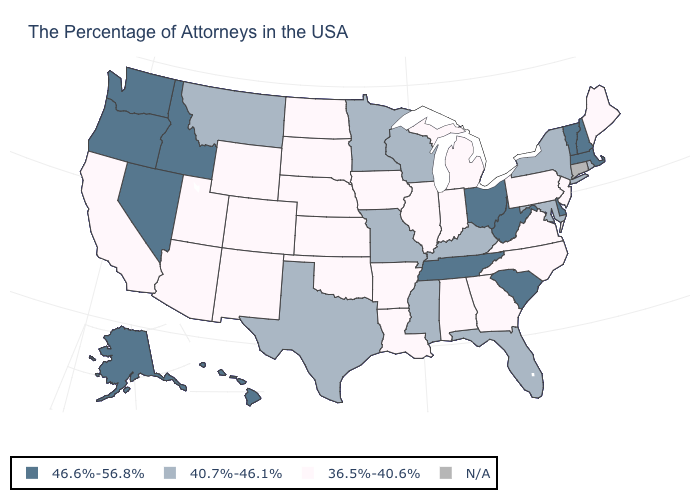What is the value of Delaware?
Be succinct. 46.6%-56.8%. What is the value of Ohio?
Keep it brief. 46.6%-56.8%. Name the states that have a value in the range 40.7%-46.1%?
Write a very short answer. Rhode Island, New York, Maryland, Florida, Kentucky, Wisconsin, Mississippi, Missouri, Minnesota, Texas, Montana. Name the states that have a value in the range 40.7%-46.1%?
Give a very brief answer. Rhode Island, New York, Maryland, Florida, Kentucky, Wisconsin, Mississippi, Missouri, Minnesota, Texas, Montana. What is the lowest value in the MidWest?
Give a very brief answer. 36.5%-40.6%. Name the states that have a value in the range 46.6%-56.8%?
Give a very brief answer. Massachusetts, New Hampshire, Vermont, Delaware, South Carolina, West Virginia, Ohio, Tennessee, Idaho, Nevada, Washington, Oregon, Alaska, Hawaii. What is the value of Iowa?
Write a very short answer. 36.5%-40.6%. What is the highest value in the Northeast ?
Be succinct. 46.6%-56.8%. Name the states that have a value in the range N/A?
Be succinct. Connecticut. What is the lowest value in the USA?
Write a very short answer. 36.5%-40.6%. What is the lowest value in the MidWest?
Quick response, please. 36.5%-40.6%. What is the highest value in the Northeast ?
Be succinct. 46.6%-56.8%. What is the value of Iowa?
Answer briefly. 36.5%-40.6%. What is the value of North Carolina?
Answer briefly. 36.5%-40.6%. What is the value of Florida?
Concise answer only. 40.7%-46.1%. 